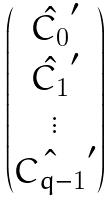<formula> <loc_0><loc_0><loc_500><loc_500>\begin{pmatrix} \hat { C _ { 0 } } ^ { \prime } \\ \hat { C _ { 1 } } ^ { \prime } \\ \vdots \\ \hat { C _ { q - 1 } } ^ { \prime } \\ \end{pmatrix}</formula> 